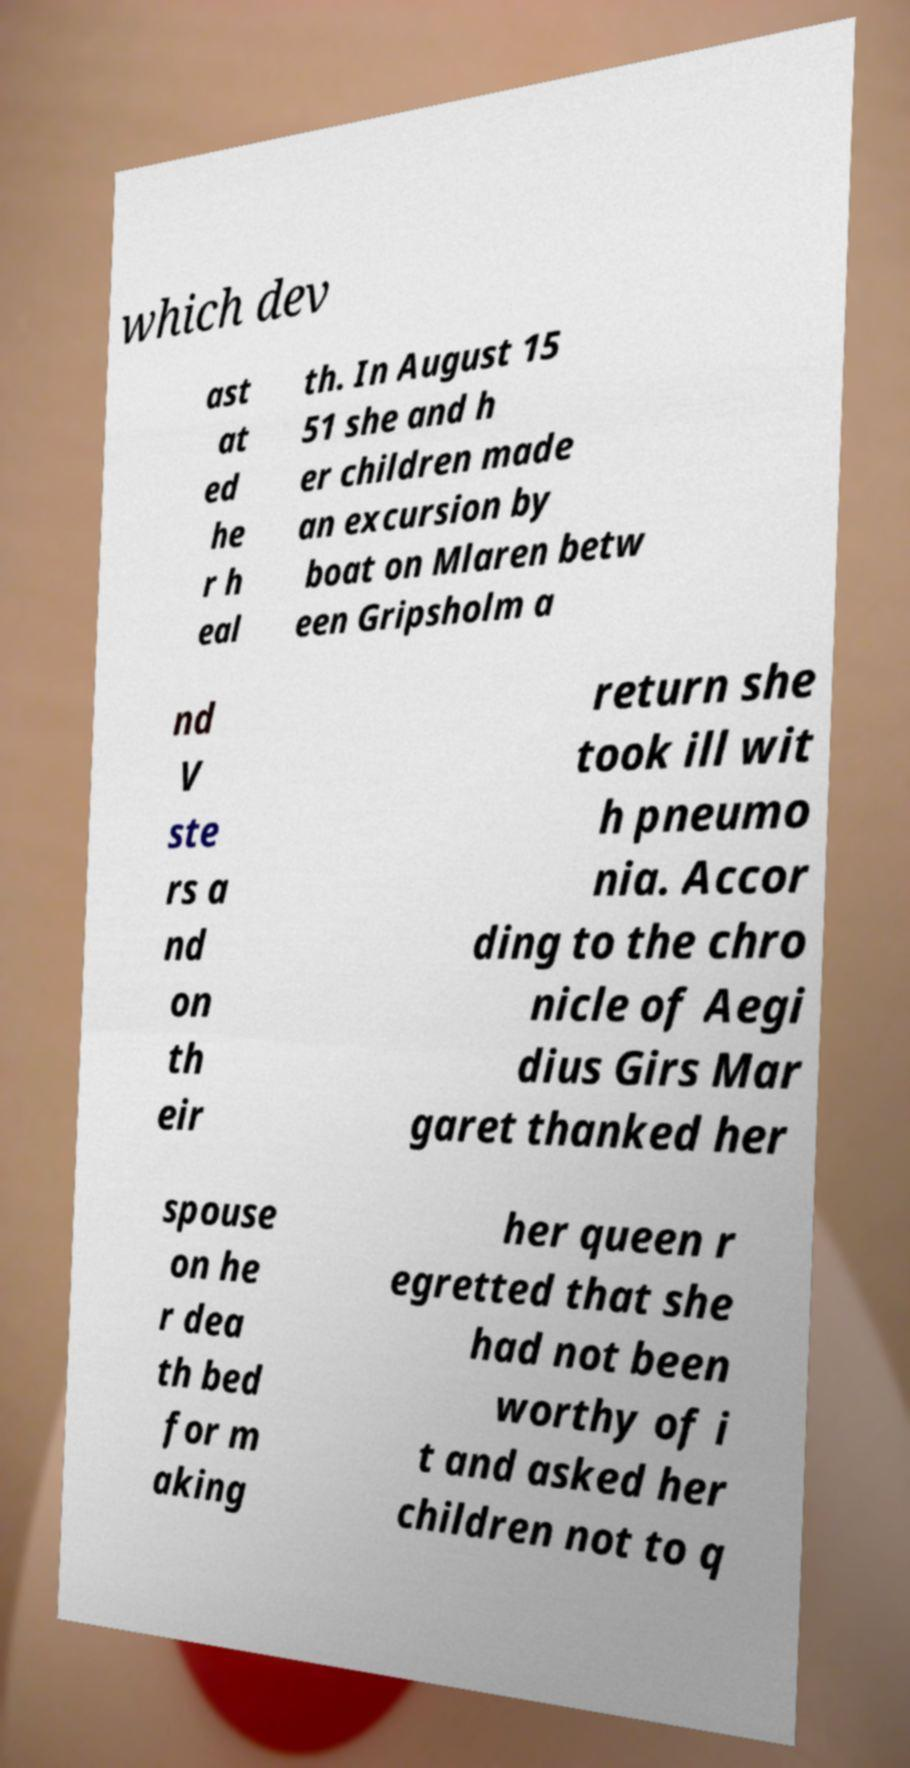Could you extract and type out the text from this image? which dev ast at ed he r h eal th. In August 15 51 she and h er children made an excursion by boat on Mlaren betw een Gripsholm a nd V ste rs a nd on th eir return she took ill wit h pneumo nia. Accor ding to the chro nicle of Aegi dius Girs Mar garet thanked her spouse on he r dea th bed for m aking her queen r egretted that she had not been worthy of i t and asked her children not to q 